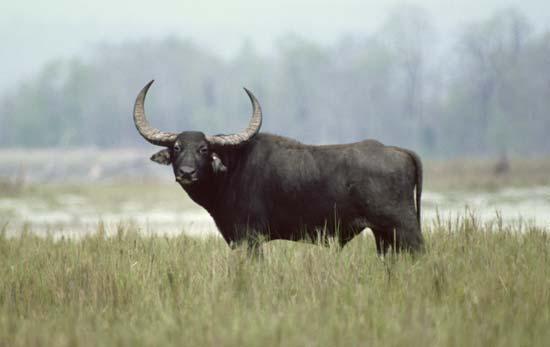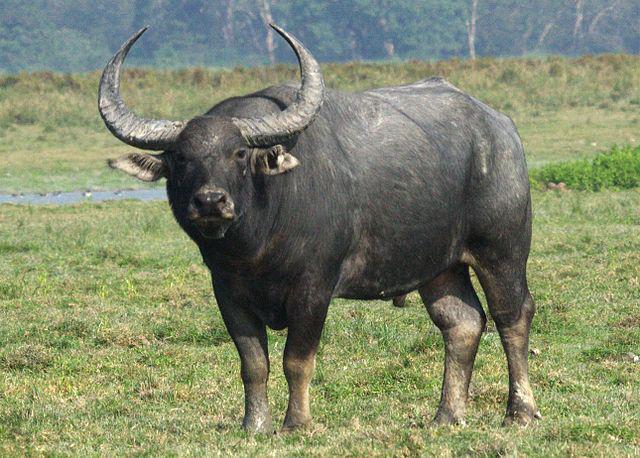The first image is the image on the left, the second image is the image on the right. Examine the images to the left and right. Is the description "At least one ox is standing in the water." accurate? Answer yes or no. No. The first image is the image on the left, the second image is the image on the right. Considering the images on both sides, is "Each image contains just one water buffalo." valid? Answer yes or no. Yes. 